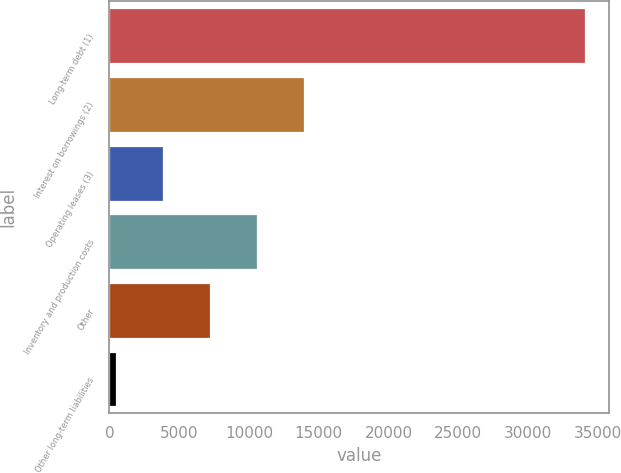Convert chart. <chart><loc_0><loc_0><loc_500><loc_500><bar_chart><fcel>Long-term debt (1)<fcel>Interest on borrowings (2)<fcel>Operating leases (3)<fcel>Inventory and production costs<fcel>Other<fcel>Other long-term liabilities<nl><fcel>34120<fcel>13928.8<fcel>3833.2<fcel>10563.6<fcel>7198.4<fcel>468<nl></chart> 